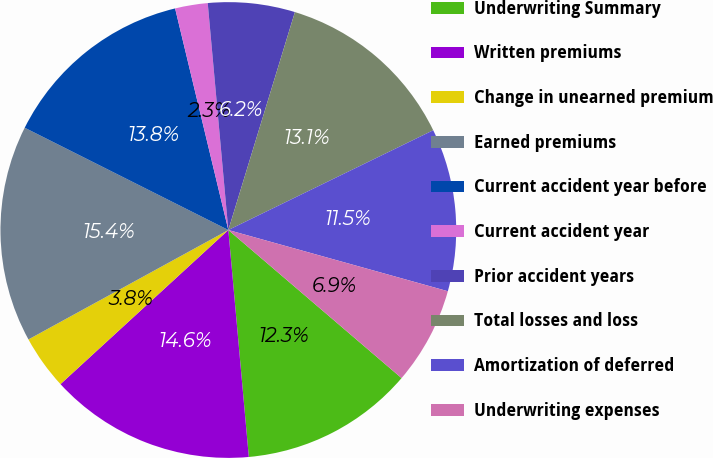<chart> <loc_0><loc_0><loc_500><loc_500><pie_chart><fcel>Underwriting Summary<fcel>Written premiums<fcel>Change in unearned premium<fcel>Earned premiums<fcel>Current accident year before<fcel>Current accident year<fcel>Prior accident years<fcel>Total losses and loss<fcel>Amortization of deferred<fcel>Underwriting expenses<nl><fcel>12.31%<fcel>14.61%<fcel>3.85%<fcel>15.38%<fcel>13.84%<fcel>2.31%<fcel>6.16%<fcel>13.07%<fcel>11.54%<fcel>6.93%<nl></chart> 